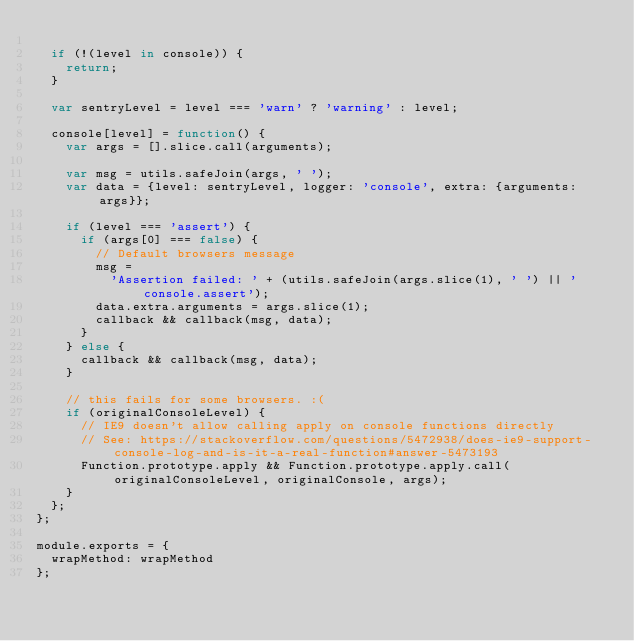Convert code to text. <code><loc_0><loc_0><loc_500><loc_500><_JavaScript_>
  if (!(level in console)) {
    return;
  }

  var sentryLevel = level === 'warn' ? 'warning' : level;

  console[level] = function() {
    var args = [].slice.call(arguments);

    var msg = utils.safeJoin(args, ' ');
    var data = {level: sentryLevel, logger: 'console', extra: {arguments: args}};

    if (level === 'assert') {
      if (args[0] === false) {
        // Default browsers message
        msg =
          'Assertion failed: ' + (utils.safeJoin(args.slice(1), ' ') || 'console.assert');
        data.extra.arguments = args.slice(1);
        callback && callback(msg, data);
      }
    } else {
      callback && callback(msg, data);
    }

    // this fails for some browsers. :(
    if (originalConsoleLevel) {
      // IE9 doesn't allow calling apply on console functions directly
      // See: https://stackoverflow.com/questions/5472938/does-ie9-support-console-log-and-is-it-a-real-function#answer-5473193
      Function.prototype.apply && Function.prototype.apply.call(originalConsoleLevel, originalConsole, args);
    }
  };
};

module.exports = {
  wrapMethod: wrapMethod
};
</code> 